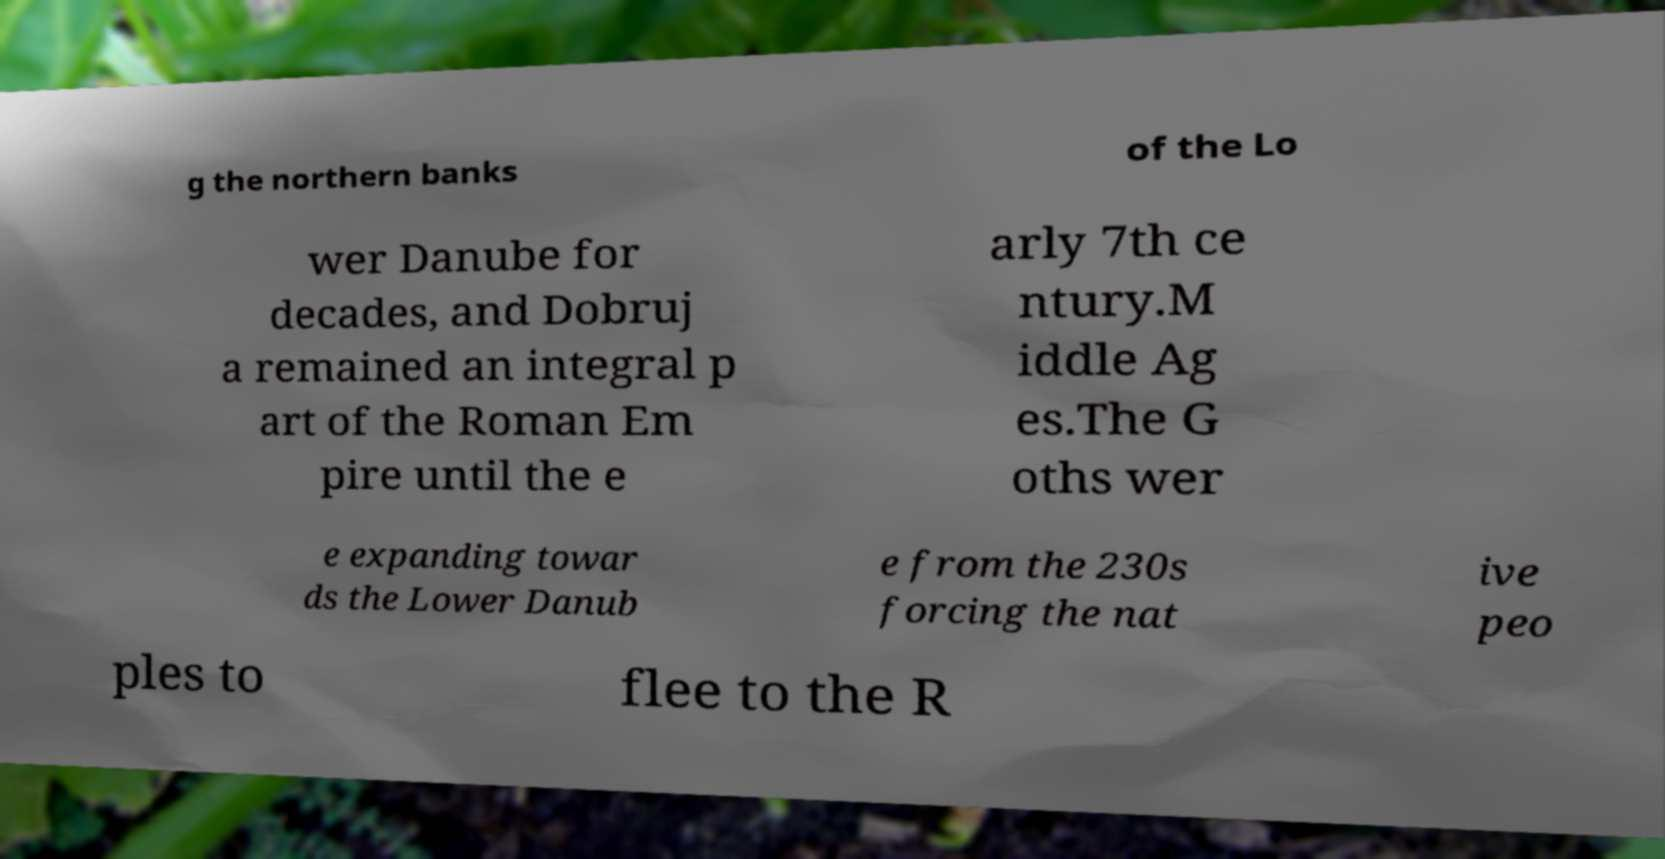There's text embedded in this image that I need extracted. Can you transcribe it verbatim? g the northern banks of the Lo wer Danube for decades, and Dobruj a remained an integral p art of the Roman Em pire until the e arly 7th ce ntury.M iddle Ag es.The G oths wer e expanding towar ds the Lower Danub e from the 230s forcing the nat ive peo ples to flee to the R 